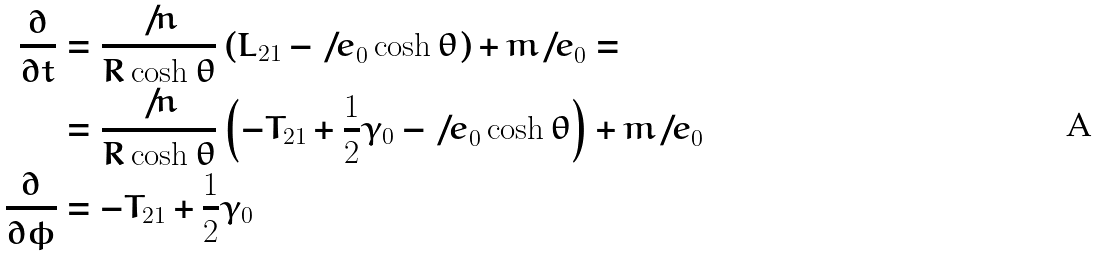<formula> <loc_0><loc_0><loc_500><loc_500>\frac { \partial } { \partial t } & = \frac { \not \, { n } } { R \cosh { \theta } } \left ( { L } _ { 2 1 } - { \not \, { e } } _ { 0 } \cosh { \theta } \right ) + m { \not \, { e } } _ { 0 } = \\ & = \frac { \not \, { n } } { R \cosh { \theta } } \left ( - { T } _ { 2 1 } + \frac { 1 } { 2 } { \gamma } _ { 0 } - { \not \, { e } } _ { 0 } \cosh { \theta } \right ) + m { \not \, { e } } _ { 0 } \\ \frac { \partial } { \partial \phi } & = - { T } _ { 2 1 } + \frac { 1 } { 2 } { \gamma } _ { 0 }</formula> 